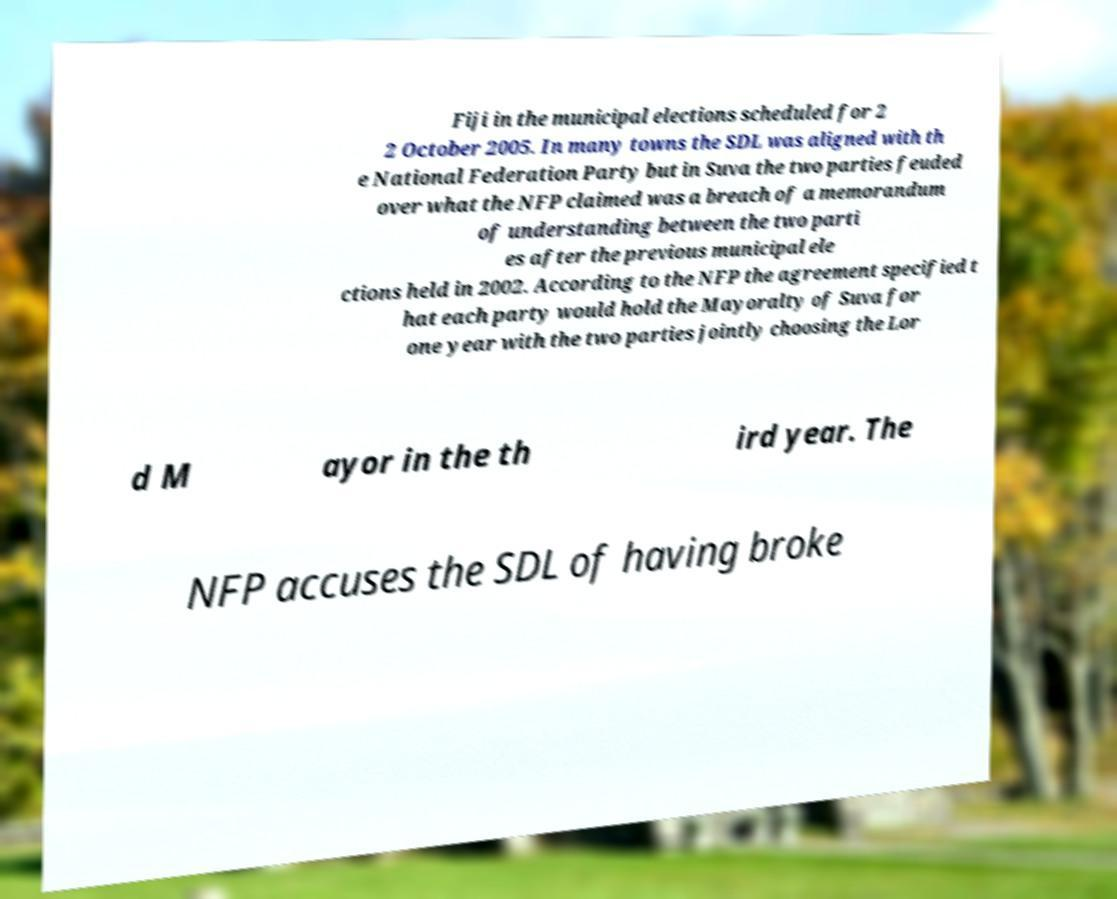Can you accurately transcribe the text from the provided image for me? Fiji in the municipal elections scheduled for 2 2 October 2005. In many towns the SDL was aligned with th e National Federation Party but in Suva the two parties feuded over what the NFP claimed was a breach of a memorandum of understanding between the two parti es after the previous municipal ele ctions held in 2002. According to the NFP the agreement specified t hat each party would hold the Mayoralty of Suva for one year with the two parties jointly choosing the Lor d M ayor in the th ird year. The NFP accuses the SDL of having broke 